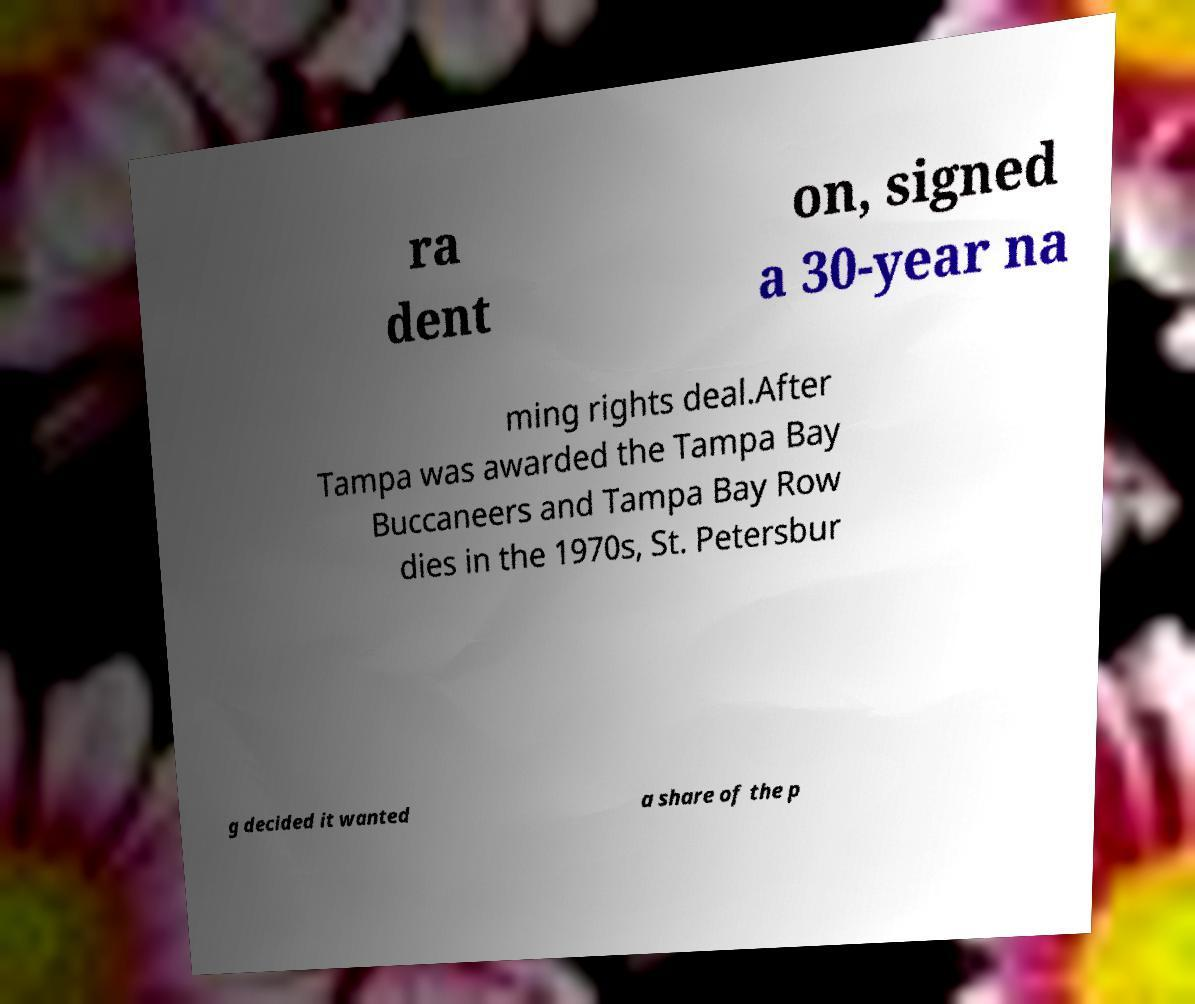There's text embedded in this image that I need extracted. Can you transcribe it verbatim? ra dent on, signed a 30-year na ming rights deal.After Tampa was awarded the Tampa Bay Buccaneers and Tampa Bay Row dies in the 1970s, St. Petersbur g decided it wanted a share of the p 